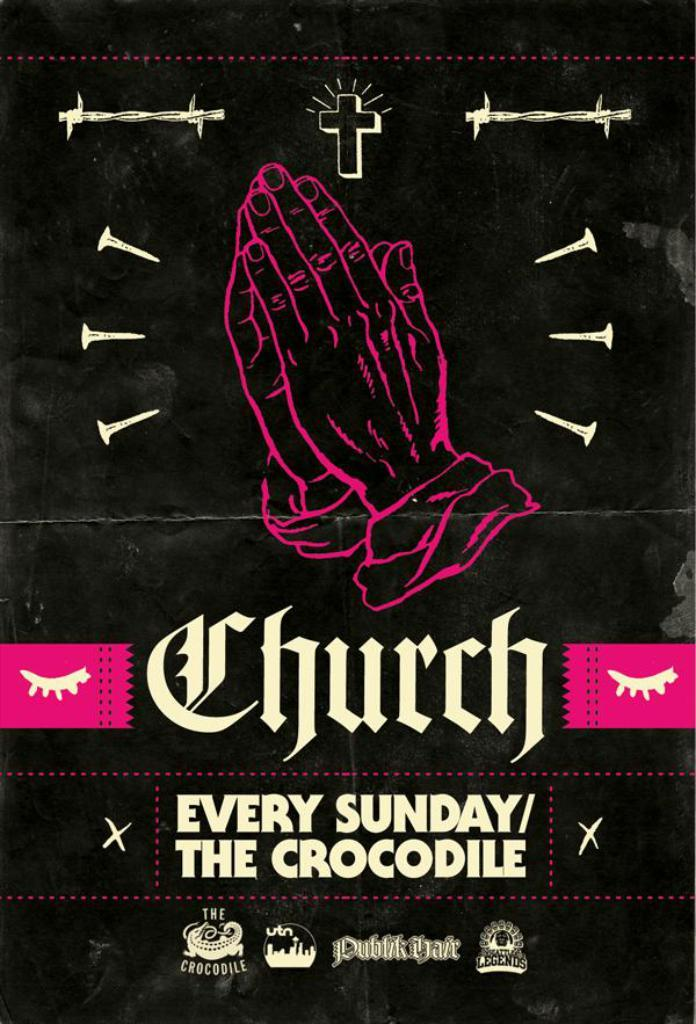<image>
Provide a brief description of the given image. Hands together in prayer on a sign about church every Sunday. 